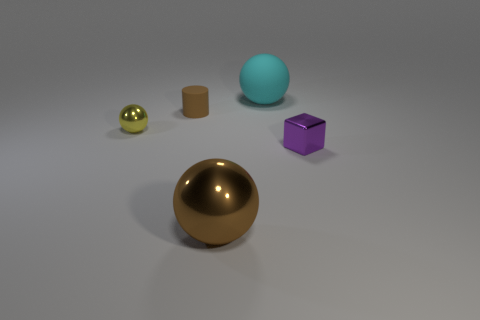Are there any large metal objects of the same color as the large shiny ball?
Offer a very short reply. No. There is a cylinder that is the same color as the large shiny object; what is it made of?
Provide a short and direct response. Rubber. How many tiny spheres are the same color as the rubber cylinder?
Offer a very short reply. 0. How many objects are either small shiny objects to the right of the big metal object or large cyan matte objects?
Provide a succinct answer. 2. The tiny block that is the same material as the yellow ball is what color?
Provide a succinct answer. Purple. Is there a cyan rubber object of the same size as the brown rubber object?
Provide a succinct answer. No. How many things are objects that are behind the cylinder or balls that are behind the small sphere?
Give a very brief answer. 1. What shape is the thing that is the same size as the cyan ball?
Offer a terse response. Sphere. Are there any tiny purple things that have the same shape as the tiny brown matte object?
Provide a succinct answer. No. Are there fewer tiny cylinders than large balls?
Offer a terse response. Yes. 